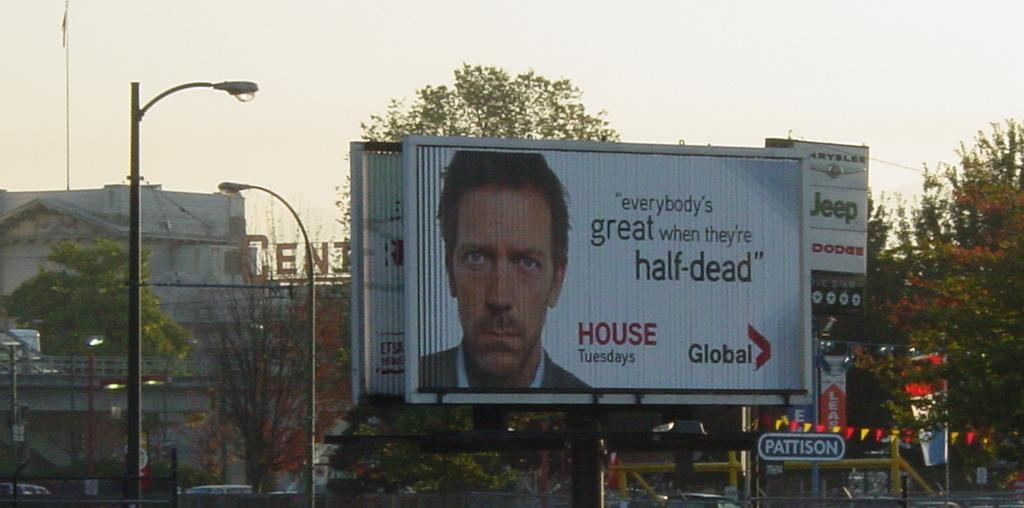<image>
Relay a brief, clear account of the picture shown. A billboard for the show House says that it plays on Tuesdays. 